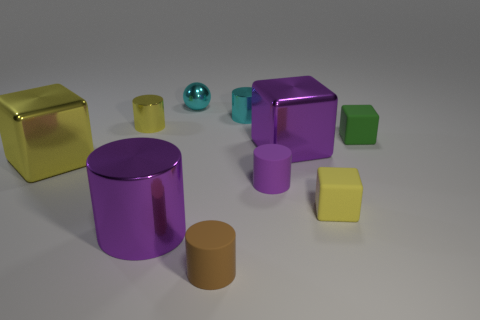There is another cylinder that is the same color as the large cylinder; what material is it?
Offer a terse response. Rubber. What is the color of the big cylinder that is the same material as the cyan sphere?
Your answer should be very brief. Purple. There is a large thing that is the same shape as the tiny brown rubber thing; what is it made of?
Keep it short and to the point. Metal. What is the shape of the brown rubber thing?
Your response must be concise. Cylinder. There is a purple thing that is in front of the purple metal cube and to the right of the large cylinder; what is it made of?
Give a very brief answer. Rubber. There is a tiny yellow thing that is the same material as the large yellow block; what is its shape?
Provide a short and direct response. Cylinder. What is the size of the purple cube that is made of the same material as the tiny cyan ball?
Your response must be concise. Large. The small thing that is behind the big yellow cube and in front of the yellow shiny cylinder has what shape?
Make the answer very short. Cube. What is the size of the thing that is behind the tiny cyan metallic object on the right side of the small cyan sphere?
Make the answer very short. Small. How many other objects are there of the same color as the small ball?
Your answer should be compact. 1. 